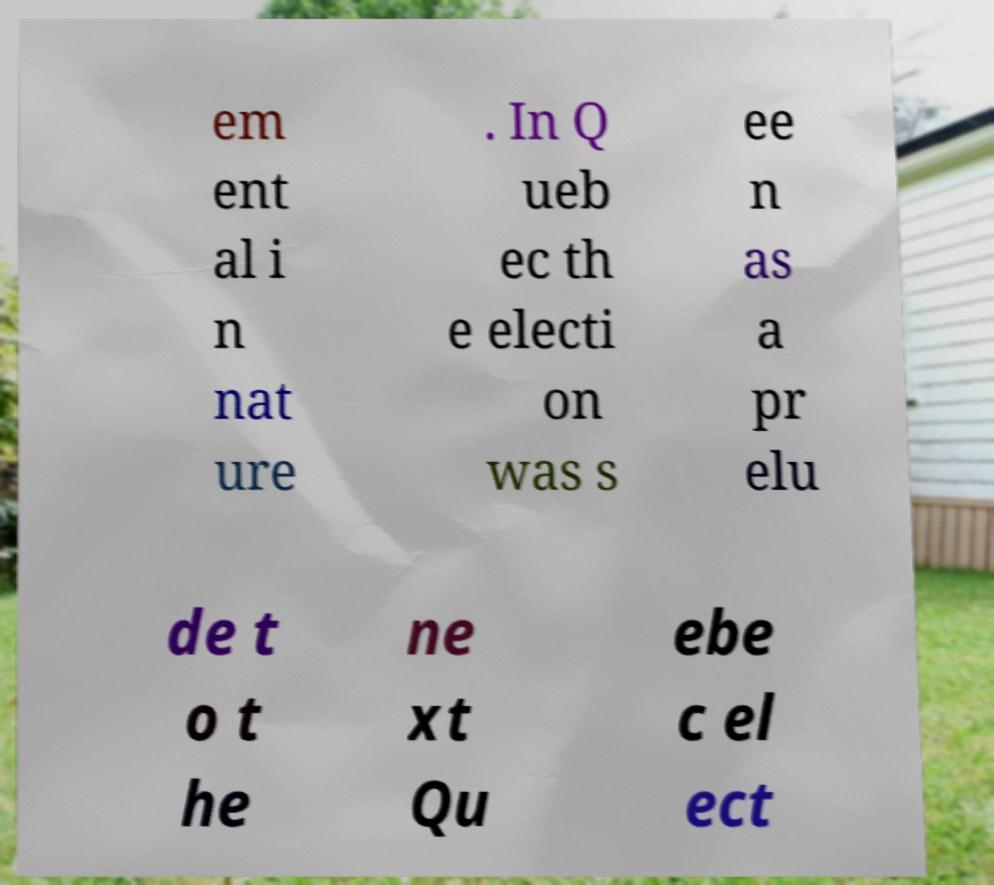I need the written content from this picture converted into text. Can you do that? em ent al i n nat ure . In Q ueb ec th e electi on was s ee n as a pr elu de t o t he ne xt Qu ebe c el ect 